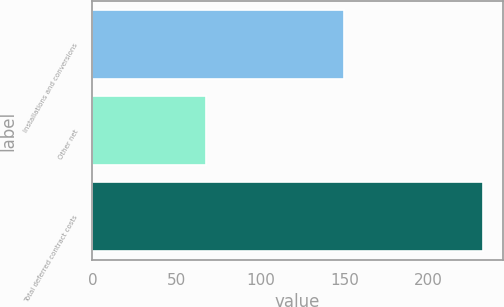<chart> <loc_0><loc_0><loc_500><loc_500><bar_chart><fcel>Installations and conversions<fcel>Other net<fcel>Total deferred contract costs<nl><fcel>149.5<fcel>67.9<fcel>232.7<nl></chart> 